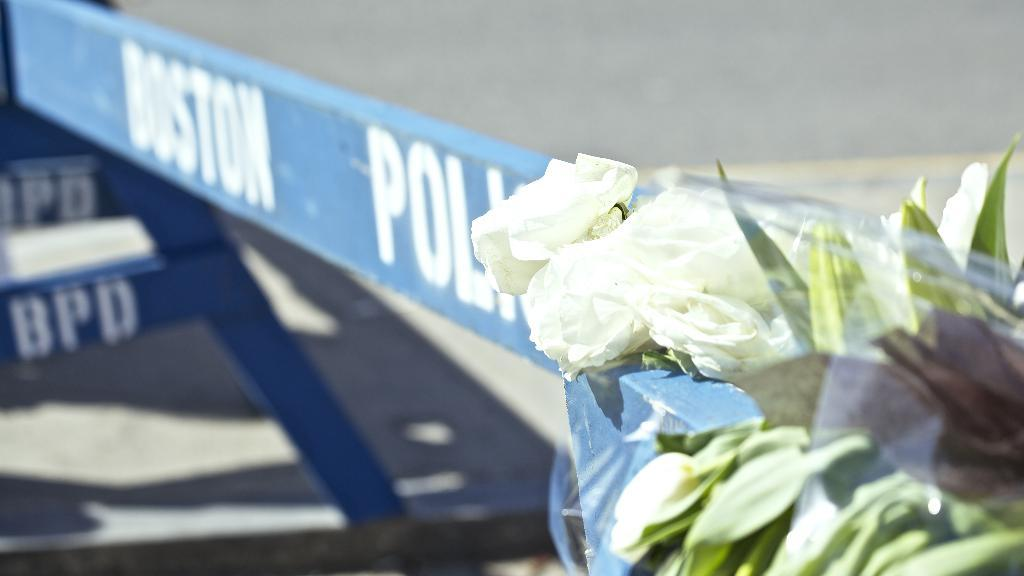What is located in the foreground of the image? There is a plant in the foreground of the image. What can be seen in the background of the image? There are boards in the background of the image. What is written or depicted on the boards? There is text on the boards. What type of surface is visible at the bottom of the image? There is a road at the bottom of the image. How does the wind affect the plant in the image? The image does not show any wind or its effects on the plant. Where might the trip to the mountain start, based on the image? The image does not show a mountain or any indication of a trip. 